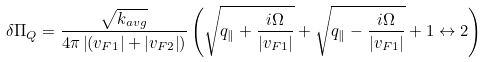Convert formula to latex. <formula><loc_0><loc_0><loc_500><loc_500>\delta \Pi _ { Q } = \frac { \sqrt { k _ { a v g } } } { 4 \pi \left | ( v _ { F 1 } \right | + \left | v _ { F 2 } \right | ) } \left ( \sqrt { q _ { \| } + \frac { i \Omega } { | v _ { F 1 } | } } + \sqrt { q _ { \| } - \frac { i \Omega } { | v _ { F 1 } | } } + 1 \leftrightarrow 2 \right )</formula> 